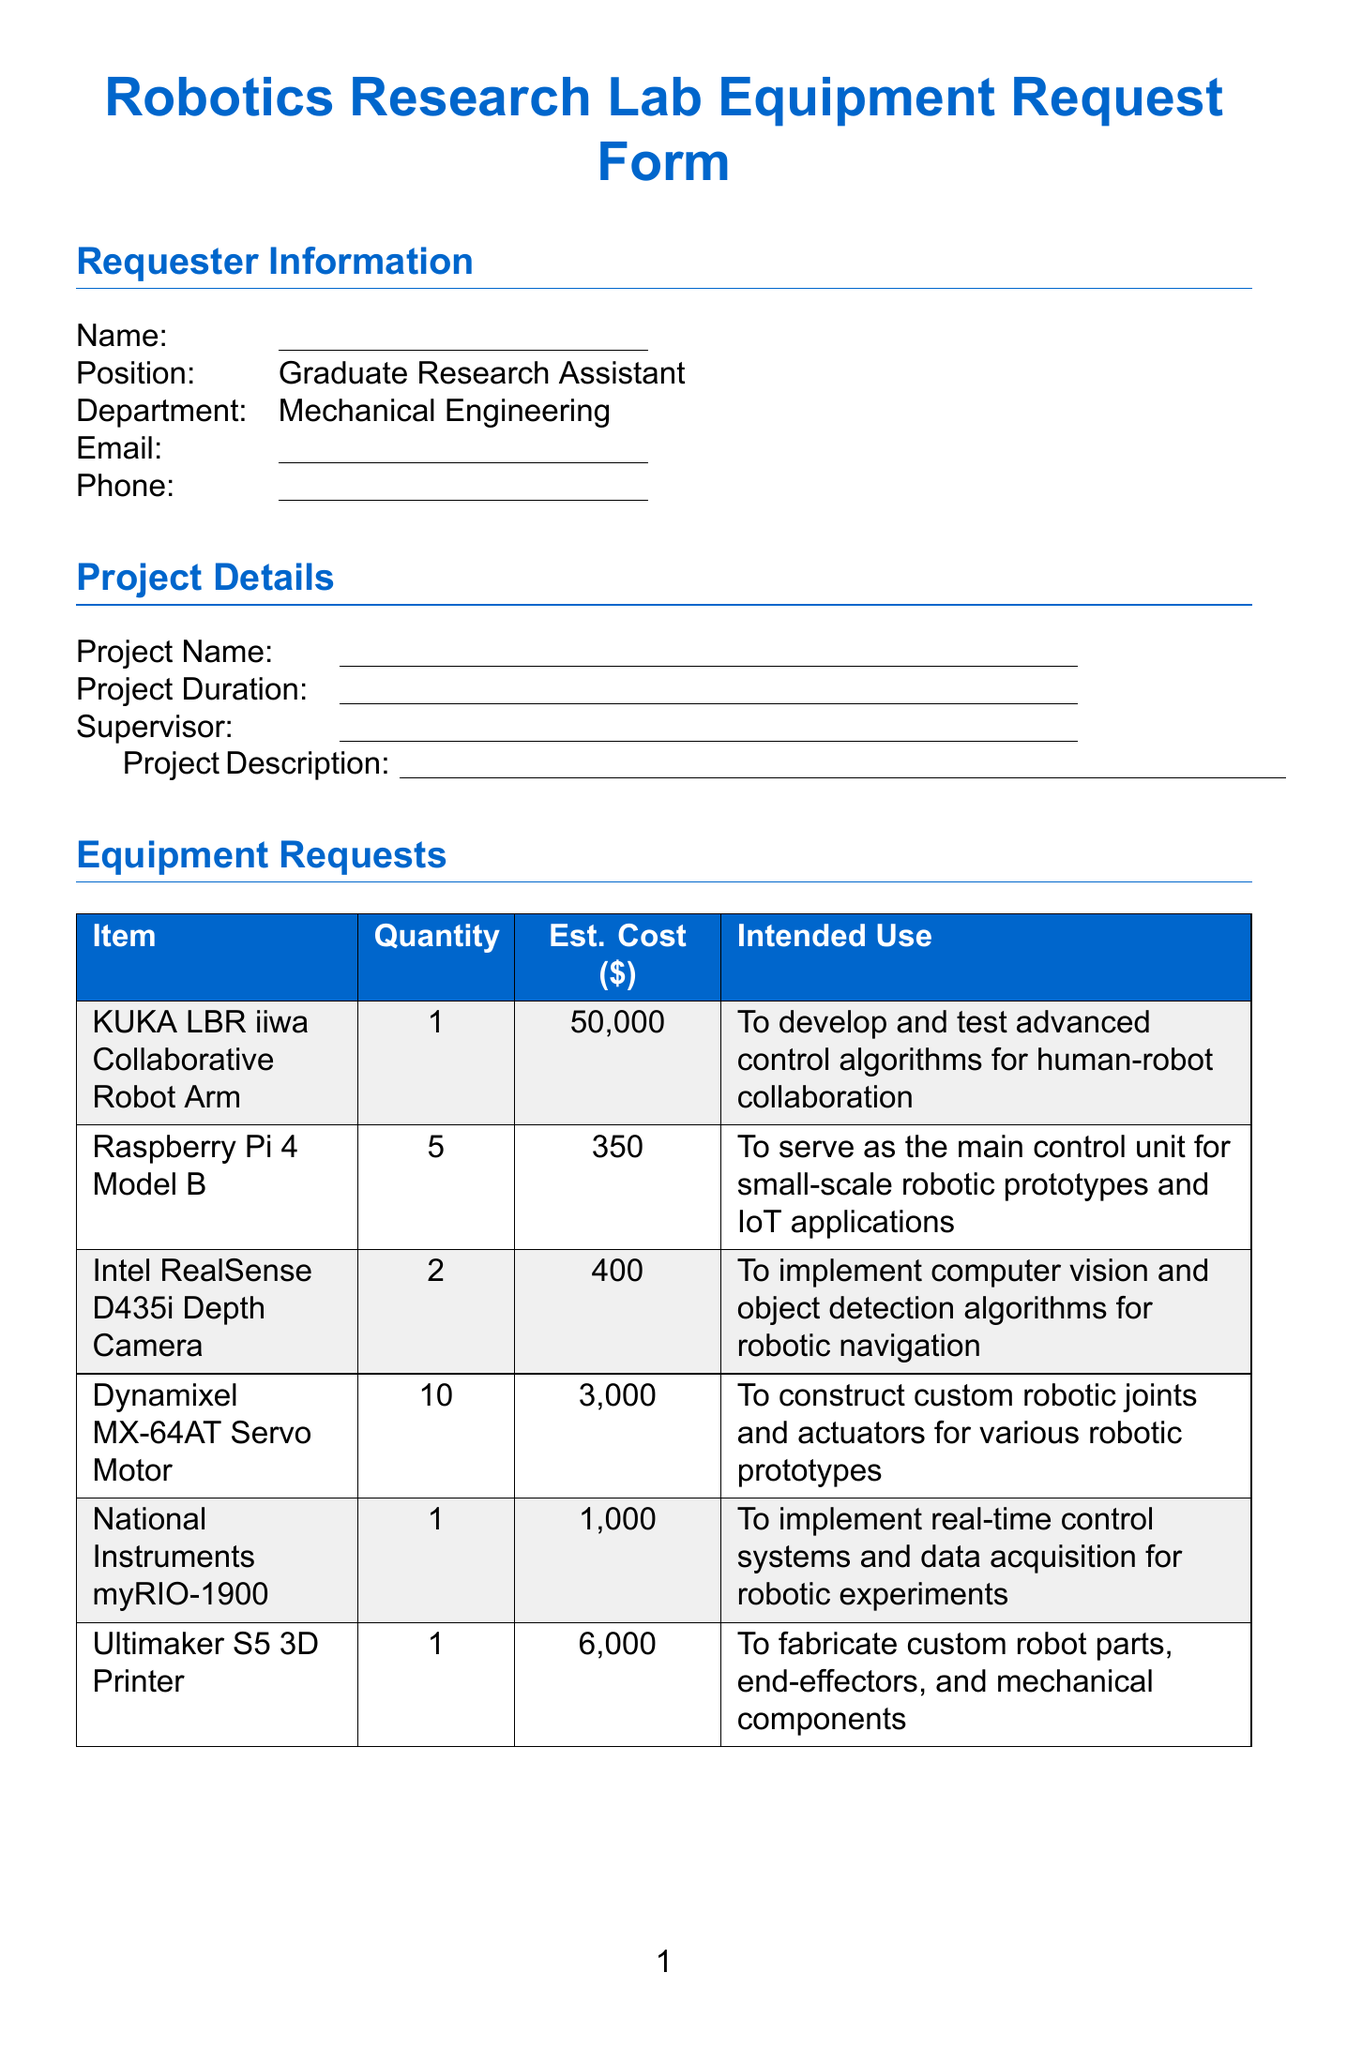what is the position of the requester? The position of the requester is listed in the document as "Graduate Research Assistant."
Answer: Graduate Research Assistant how many KUKA LBR iiwa Collaborative Robot Arms are requested? The document specifies that the quantity of KUKA LBR iiwa Collaborative Robot Arms requested is 1.
Answer: 1 what is the intended use of the Intel RealSense D435i Depth Camera? The intended use of this camera is mentioned as implementing computer vision and object detection algorithms for robotic navigation and manipulation.
Answer: To implement computer vision and object detection algorithms for robotic navigation and manipulation what is the estimated cost of the Ultimaker S5 3D Printer? The document mentions that the estimated cost of the Ultimaker S5 3D Printer is 6000 dollars.
Answer: 6000 which software has an estimated cost of 500 dollars? The document indicates that "MATLAB with Robotics System Toolbox" has an estimated cost of 500 dollars.
Answer: MATLAB with Robotics System Toolbox how many Dynamixel MX-64AT Servo Motors are requested? The quantity requested for Dynamixel MX-64AT Servo Motors is stated as 10 in the document.
Answer: 10 what is the total estimated cost of all requested equipment? The total estimated cost can be calculated by summing up the individual equipment costs mentioned in the document.
Answer: 58050 what training is required for safety? The document lists "Lab Safety Orientation," "Robotics Equipment Handling," and "Electrical Safety" as required training.
Answer: Lab Safety Orientation, Robotics Equipment Handling, Electrical Safety who needs to approve the equipment request? The approval signatures required are from the requester, supervisor, department head, and lab manager.
Answer: Requester, Supervisor, Department Head, Lab Manager 